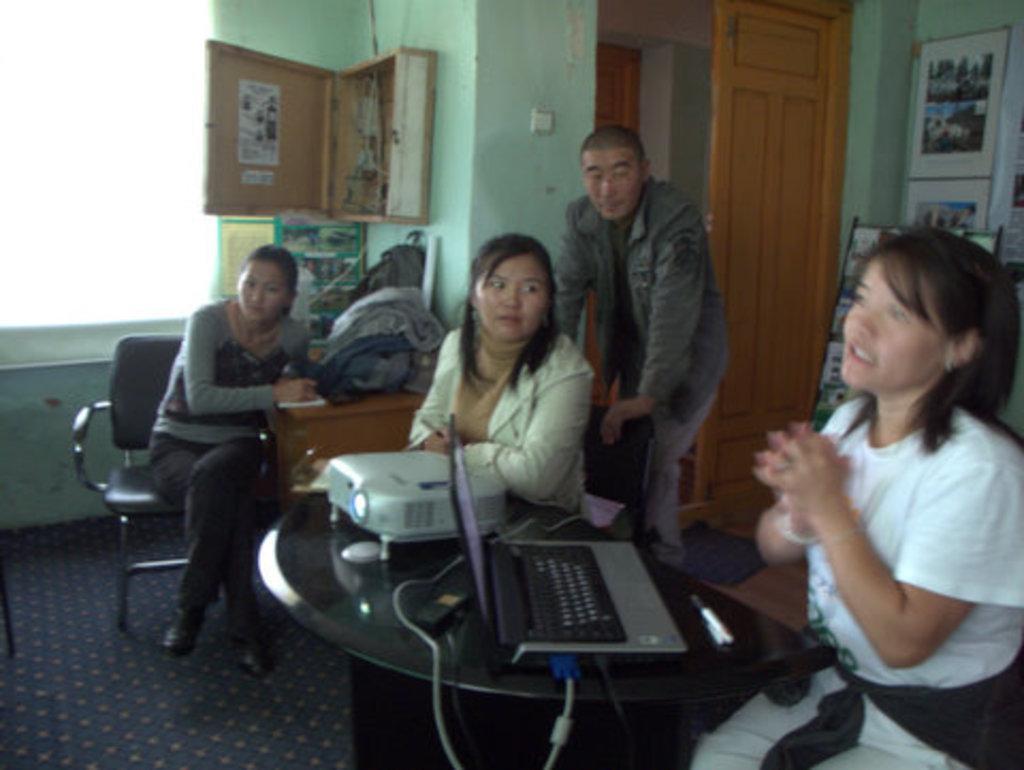How would you summarize this image in a sentence or two? The image is taken inside house, some people are sitting around the table, on the table there is a projector machine and a laptop, to the wall there is a table on the table there are some bags, in the background there is a green color wall and a door. 